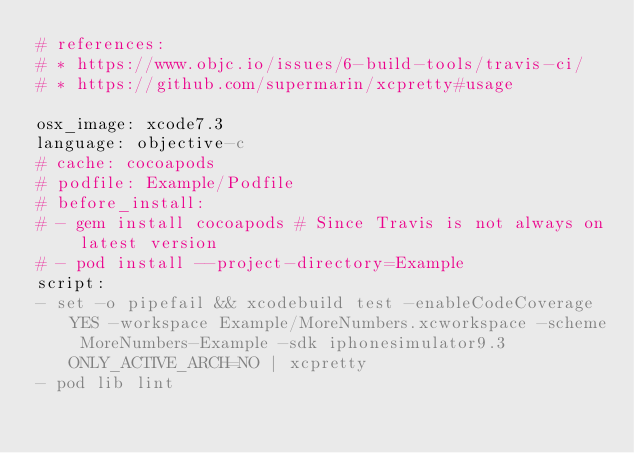Convert code to text. <code><loc_0><loc_0><loc_500><loc_500><_YAML_># references:
# * https://www.objc.io/issues/6-build-tools/travis-ci/
# * https://github.com/supermarin/xcpretty#usage

osx_image: xcode7.3
language: objective-c
# cache: cocoapods
# podfile: Example/Podfile
# before_install:
# - gem install cocoapods # Since Travis is not always on latest version
# - pod install --project-directory=Example
script:
- set -o pipefail && xcodebuild test -enableCodeCoverage YES -workspace Example/MoreNumbers.xcworkspace -scheme MoreNumbers-Example -sdk iphonesimulator9.3 ONLY_ACTIVE_ARCH=NO | xcpretty
- pod lib lint
</code> 